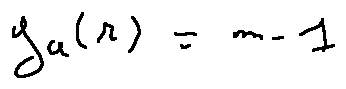<formula> <loc_0><loc_0><loc_500><loc_500>g _ { a } ( r ) = m - 1</formula> 